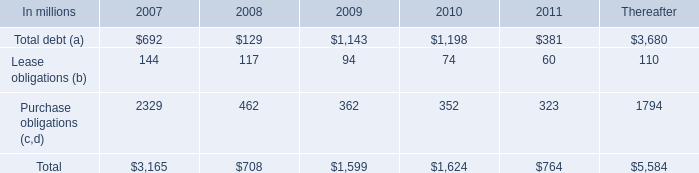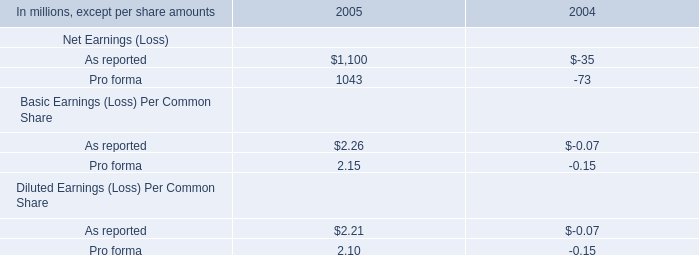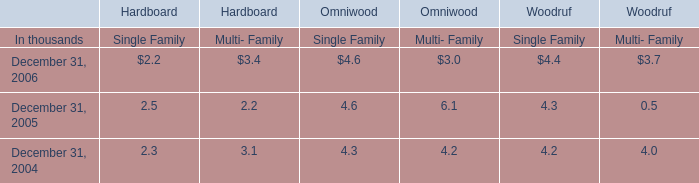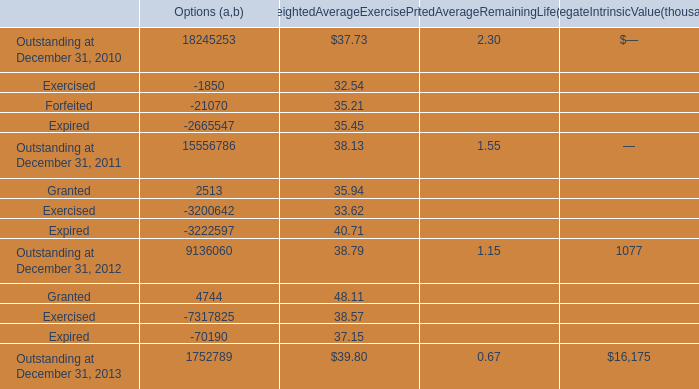Does the average value ofExercised in 2010 greater than that in 2011? 
Answer: yes. 